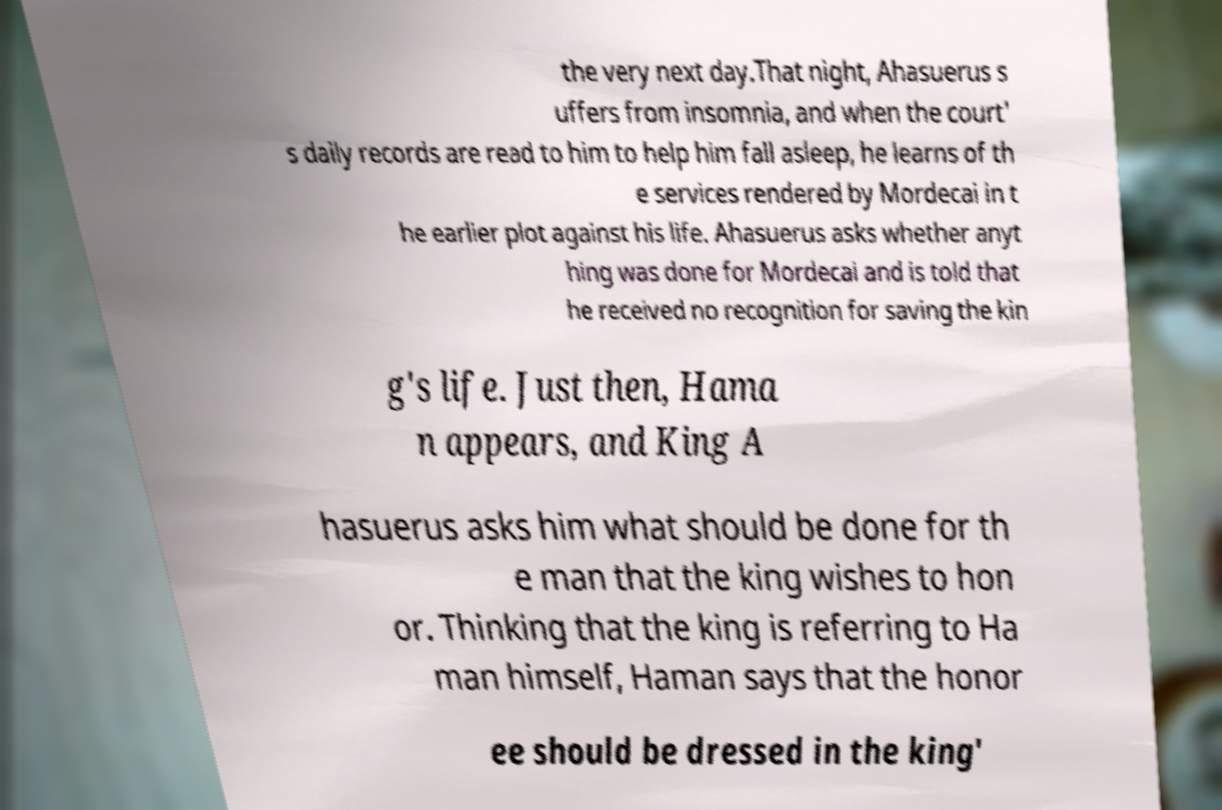Could you assist in decoding the text presented in this image and type it out clearly? the very next day.That night, Ahasuerus s uffers from insomnia, and when the court' s daily records are read to him to help him fall asleep, he learns of th e services rendered by Mordecai in t he earlier plot against his life. Ahasuerus asks whether anyt hing was done for Mordecai and is told that he received no recognition for saving the kin g's life. Just then, Hama n appears, and King A hasuerus asks him what should be done for th e man that the king wishes to hon or. Thinking that the king is referring to Ha man himself, Haman says that the honor ee should be dressed in the king' 